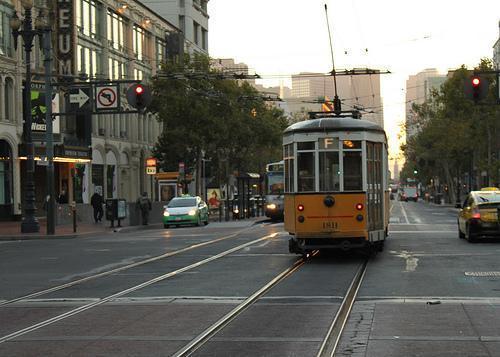How many trolleys are in the picture?
Give a very brief answer. 1. 